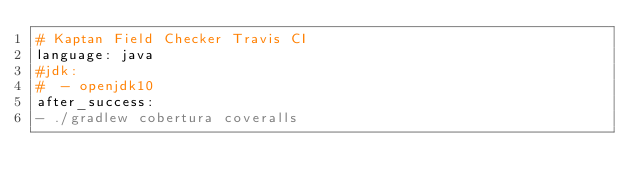Convert code to text. <code><loc_0><loc_0><loc_500><loc_500><_YAML_># Kaptan Field Checker Travis CI
language: java
#jdk:
#  - openjdk10
after_success:
- ./gradlew cobertura coveralls
</code> 